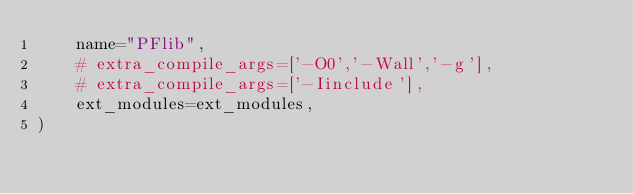Convert code to text. <code><loc_0><loc_0><loc_500><loc_500><_Python_>    name="PFlib",
    # extra_compile_args=['-O0','-Wall','-g'],
    # extra_compile_args=['-Iinclude'],
    ext_modules=ext_modules,
)</code> 